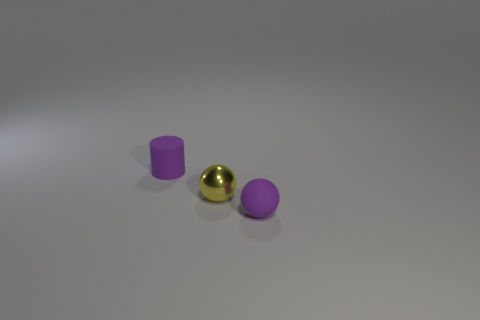Add 3 purple cylinders. How many objects exist? 6 Subtract all cylinders. How many objects are left? 2 Subtract 0 red cylinders. How many objects are left? 3 Subtract all small purple matte cylinders. Subtract all gray rubber cylinders. How many objects are left? 2 Add 2 metal spheres. How many metal spheres are left? 3 Add 3 small blue matte cylinders. How many small blue matte cylinders exist? 3 